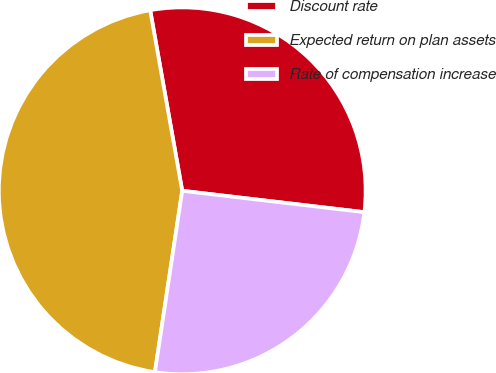<chart> <loc_0><loc_0><loc_500><loc_500><pie_chart><fcel>Discount rate<fcel>Expected return on plan assets<fcel>Rate of compensation increase<nl><fcel>29.66%<fcel>44.83%<fcel>25.52%<nl></chart> 